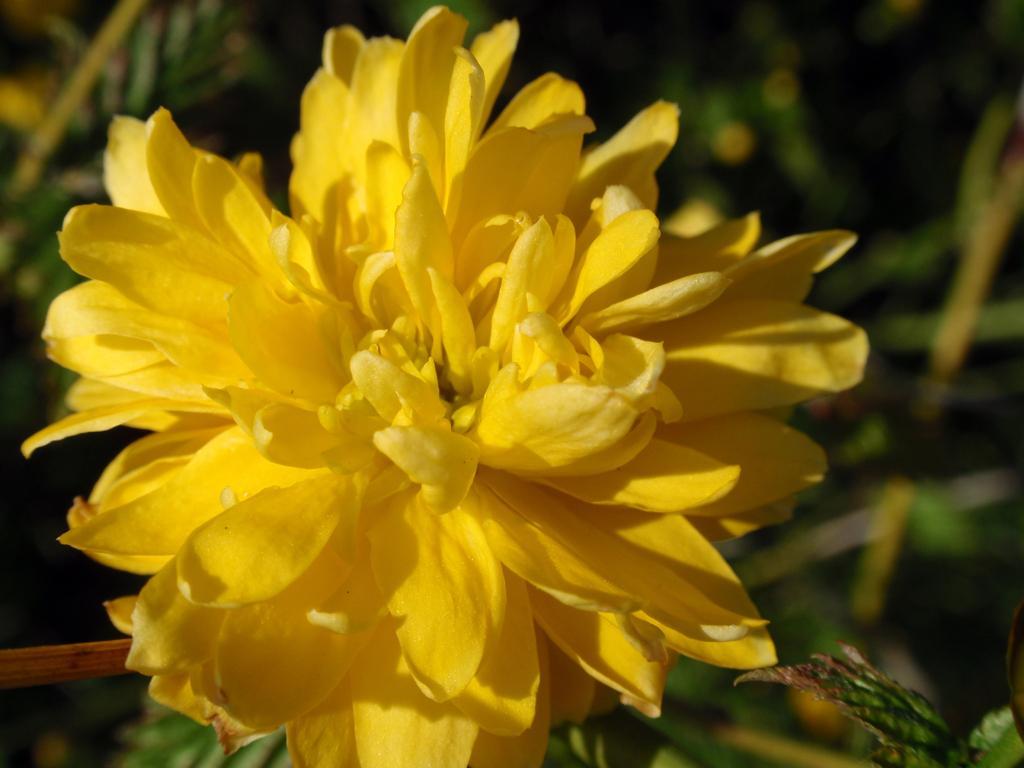In one or two sentences, can you explain what this image depicts? In the center of the image, there is a flower and in the background, there are plants. 